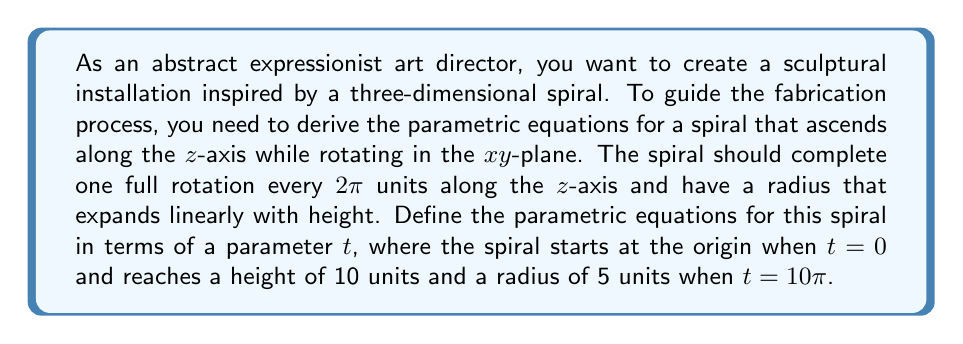Give your solution to this math problem. To derive the parametric equations for this three-dimensional spiral, we'll follow these steps:

1) First, let's consider the projection of the spiral onto the xy-plane. This will be a circle with a radius that increases linearly with height. We can express this as:

   $x = r \cos(\theta)$
   $y = r \sin(\theta)$

   where $r$ is the radius and $\theta$ is the angle of rotation.

2) We know that one full rotation occurs every 2π units along the z-axis. This means that:

   $\theta = \frac{z}{2}$

3) The radius $r$ should expand linearly with height. When z = 0, r = 0, and when z = 10, r = 5. We can express this linear relationship as:

   $r = \frac{1}{2}z$

4) Now, let's introduce our parameter t. We want z to range from 0 to 10 as t goes from 0 to 10π. This gives us:

   $z = \frac{t}{\pi}$

5) Substituting this into our expressions for $\theta$ and $r$:

   $\theta = \frac{t}{2\pi}$
   $r = \frac{t}{2\pi}$

6) Now we can write our parametric equations:

   $x = \frac{t}{2\pi} \cos(\frac{t}{2\pi})$
   $y = \frac{t}{2\pi} \sin(\frac{t}{2\pi})$
   $z = \frac{t}{\pi}$

7) To verify:
   - When t = 0, (x, y, z) = (0, 0, 0)
   - When t = 10π, z = 10, r = 5, and a full 5 rotations have occurred.

These equations define a spiral that meets all the specified criteria.
Answer: The parametric equations for the three-dimensional spiral are:

$$x = \frac{t}{2\pi} \cos(\frac{t}{2\pi})$$
$$y = \frac{t}{2\pi} \sin(\frac{t}{2\pi})$$
$$z = \frac{t}{\pi}$$

where $0 \leq t \leq 10\pi$ 